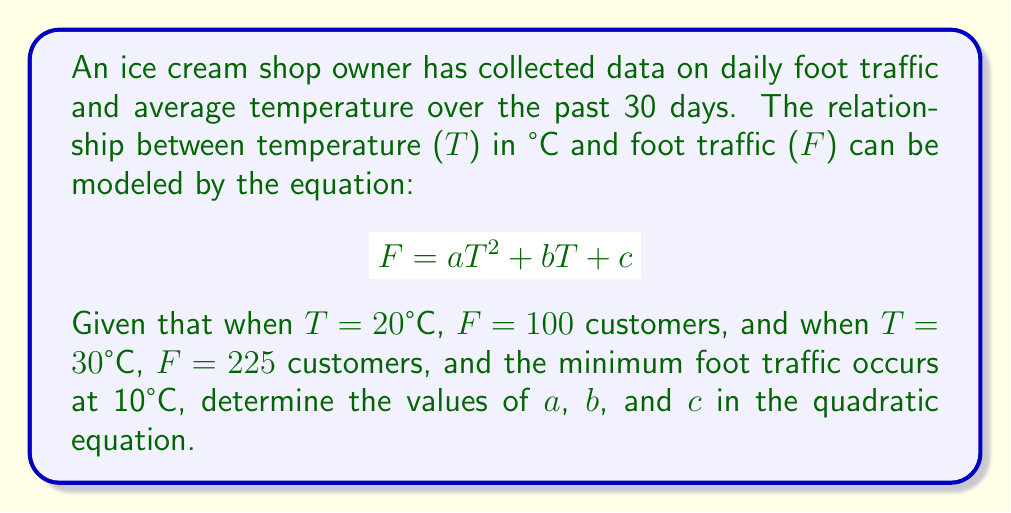Teach me how to tackle this problem. 1. We have three pieces of information to solve for a, b, and c:
   - When T = 20°C, F = 100
   - When T = 30°C, F = 225
   - Minimum foot traffic occurs at T = 10°C

2. Let's start by setting up two equations using the given points:
   $$100 = 400a + 20b + c$$ (Equation 1)
   $$225 = 900a + 30b + c$$ (Equation 2)

3. For the minimum point, we know that the derivative of F with respect to T is zero at T = 10°C:
   $$\frac{dF}{dT} = 2aT + b = 0$$
   $$20a + b = 0$$ (Equation 3)

4. Subtracting Equation 1 from Equation 2:
   $$125 = 500a + 10b$$

5. Solving for b in terms of a:
   $$b = 12.5 - 50a$$ (Equation 4)

6. Substituting this into Equation 3:
   $$20a + (12.5 - 50a) = 0$$
   $$-30a + 12.5 = 0$$
   $$a = \frac{5}{12}$$

7. Substituting a back into Equation 4:
   $$b = 12.5 - 50(\frac{5}{12}) = -8.33$$

8. Using these values in Equation 1:
   $$100 = 400(\frac{5}{12}) + 20(-8.33) + c$$
   $$100 = 166.67 - 166.6 + c$$
   $$c = 99.93$$

9. Rounding to two decimal places:
   $$a = 0.42, b = -8.33, c = 99.93$$
Answer: $a = 0.42, b = -8.33, c = 99.93$ 